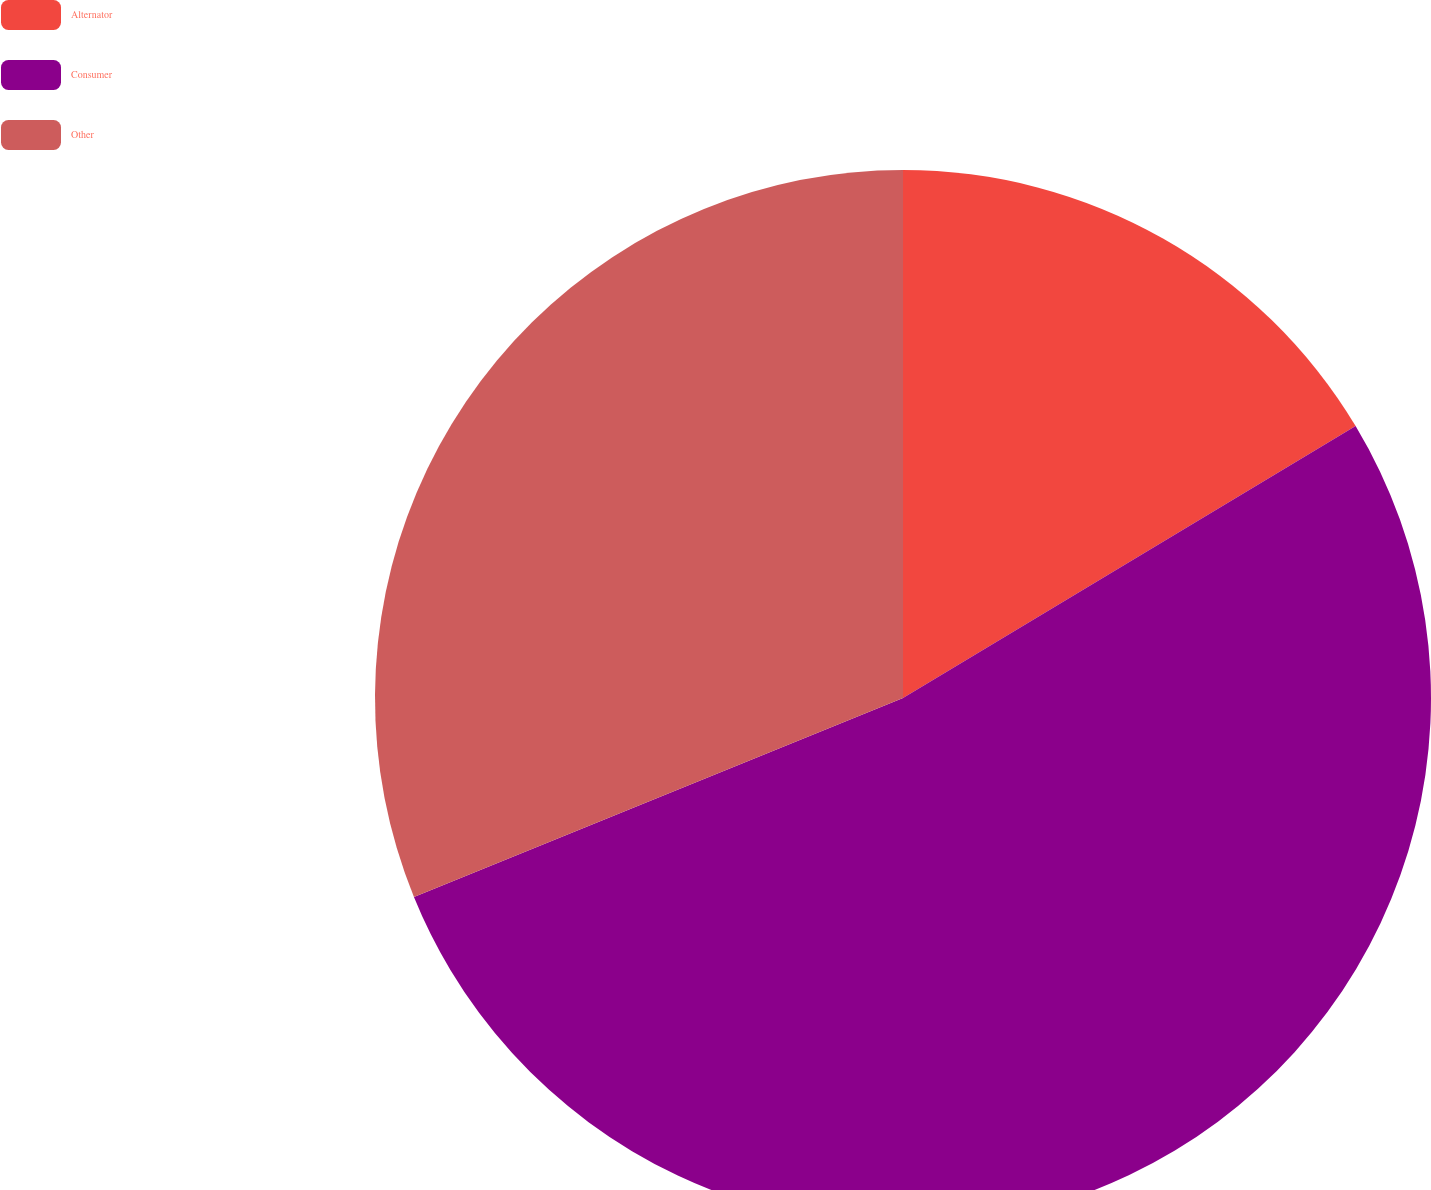Convert chart to OTSL. <chart><loc_0><loc_0><loc_500><loc_500><pie_chart><fcel>Alternator<fcel>Consumer<fcel>Other<nl><fcel>16.39%<fcel>52.46%<fcel>31.15%<nl></chart> 